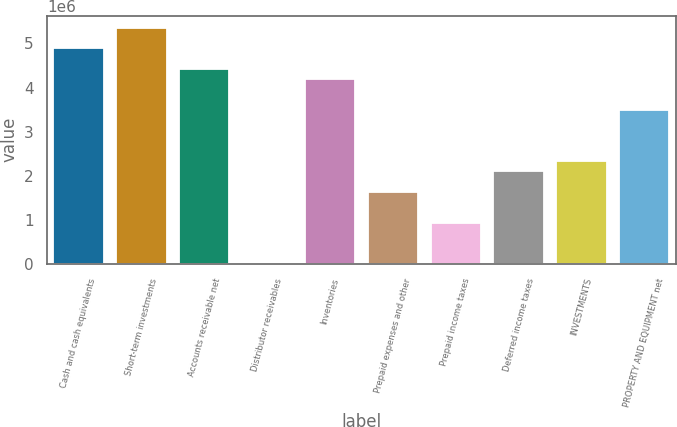Convert chart. <chart><loc_0><loc_0><loc_500><loc_500><bar_chart><fcel>Cash and cash equivalents<fcel>Short-term investments<fcel>Accounts receivable net<fcel>Distributor receivables<fcel>Inventories<fcel>Prepaid expenses and other<fcel>Prepaid income taxes<fcel>Deferred income taxes<fcel>INVESTMENTS<fcel>PROPERTY AND EQUIPMENT net<nl><fcel>4.89346e+06<fcel>5.35946e+06<fcel>4.42747e+06<fcel>552<fcel>4.19448e+06<fcel>1.63152e+06<fcel>932535<fcel>2.09751e+06<fcel>2.33051e+06<fcel>3.49549e+06<nl></chart> 